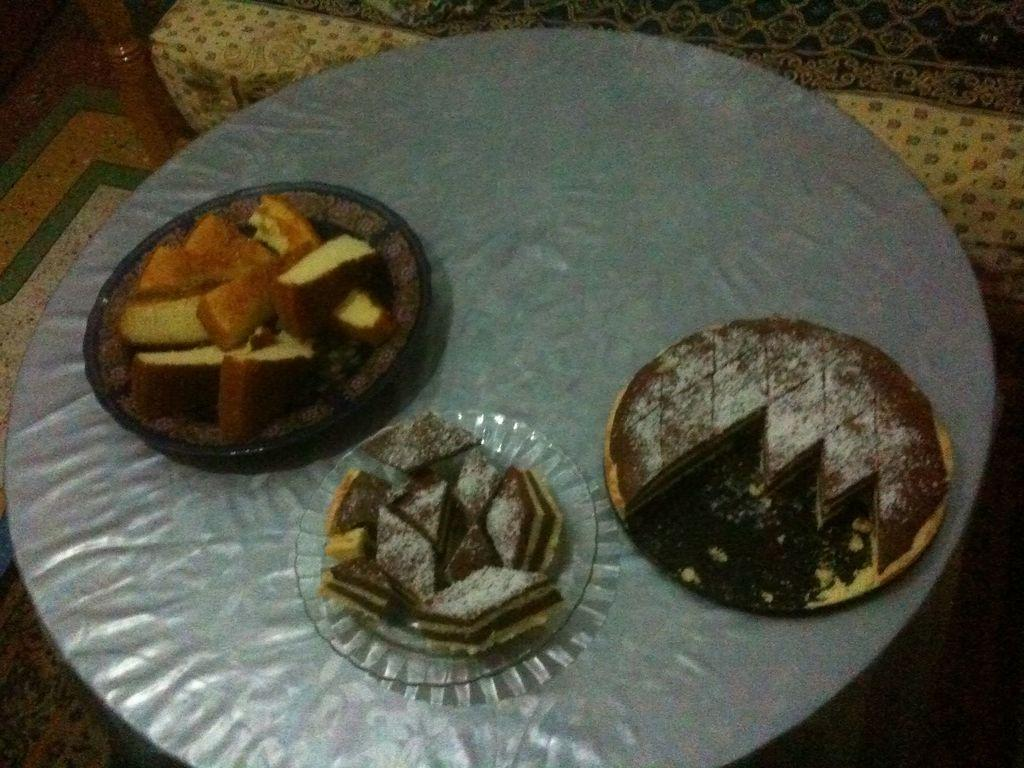What piece of furniture is in the image? There is a table in the image. What is on the table? There are plates on the table, and the plates contain sweets and cake pieces. What type of seating is visible in the image? There is a sofa present in the image. Can you see a flock of birds flying over the seashore in the image? There is no seashore or flock of birds present in the image. 